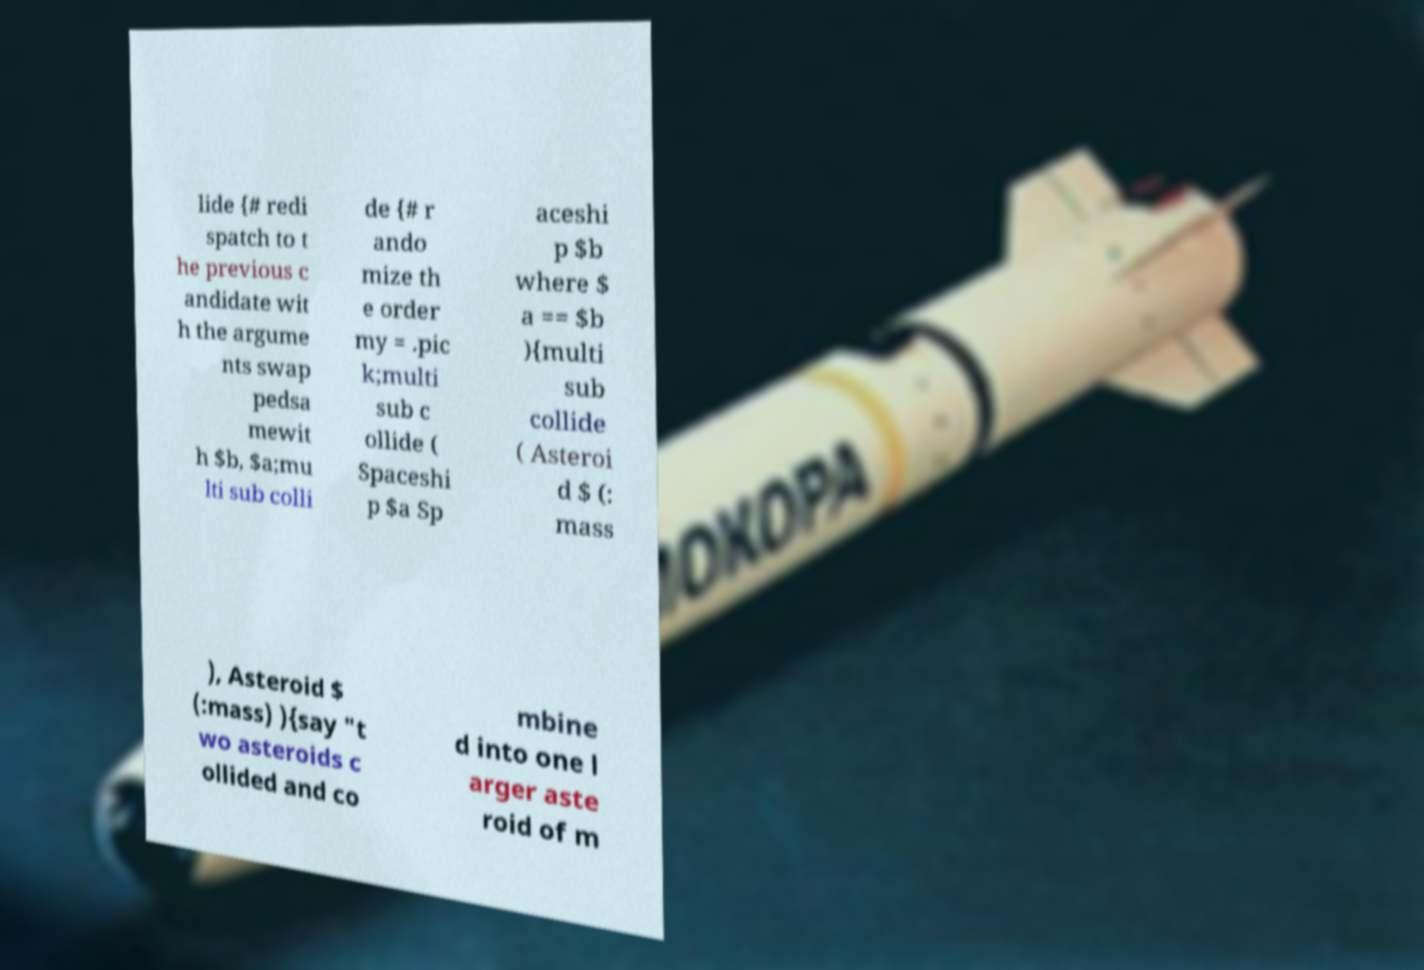Can you read and provide the text displayed in the image?This photo seems to have some interesting text. Can you extract and type it out for me? lide {# redi spatch to t he previous c andidate wit h the argume nts swap pedsa mewit h $b, $a;mu lti sub colli de {# r ando mize th e order my = .pic k;multi sub c ollide ( Spaceshi p $a Sp aceshi p $b where $ a == $b ){multi sub collide ( Asteroi d $ (: mass ), Asteroid $ (:mass) ){say "t wo asteroids c ollided and co mbine d into one l arger aste roid of m 